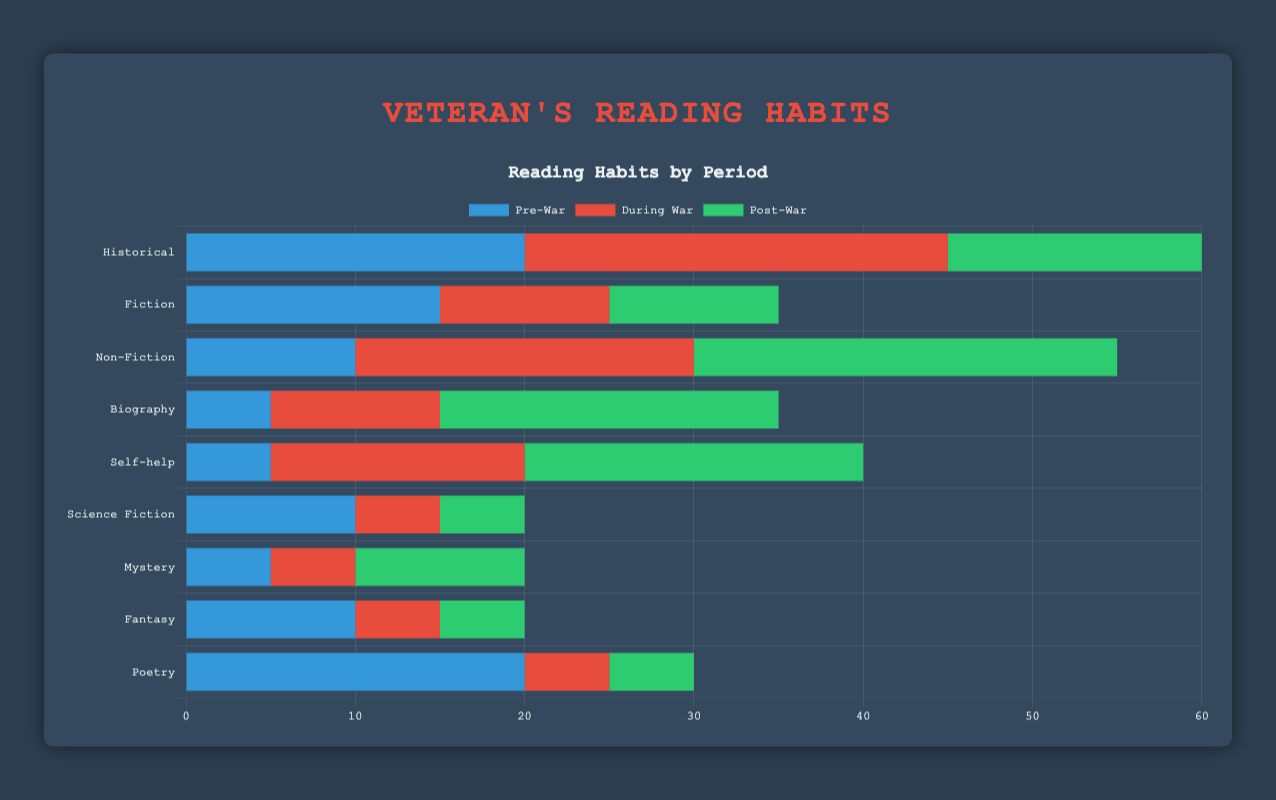What genre saw the biggest increase in reading during the war compared to pre-war? To find the biggest increase, we need to check the differences for each genre between the pre-war and during-war periods. For example, Historical increased by 25 - 20 = 5, Non-Fiction increased by 20 - 10 = 10, etc. After checking all genres, Non-Fiction has the highest increase (10).
Answer: Non-Fiction Which genre had the highest reading percentage post-war? By comparing the numbers in the post-war period, the highest value is for Non-Fiction at 25. Hence, Non-Fiction had the highest reading percentage post-war.
Answer: Non-Fiction How did poetry reading change from the pre-war to the post-war period? Poetry reading went from 20 in the pre-war period to 5 in the post-war period. Therefore, it decreased by 20 - 5 = 15.
Answer: Decreased by 15 Which periods had equal reading values for Fantasy? By checking each period for Fantasy, we see that in the pre-war and post-war periods, both values are 10 and 5, respectively.
Answer: None What is the total reading count for Science Fiction across all periods? Summing up Science Fiction values for all periods: 10 (pre-war) + 5 (during war) + 5 (post-war) = 20.
Answer: 20 In which period did Self-help and Biography have the same readings? By checking each period, we see that both genres had the same reading value of 20 in the post-war period.
Answer: Post-war Which genre experienced an increase in reading during the war and again post-war? Checking the changes in each genre, Biography increased from 5 (pre-war) to 10 (during war) to 20 (post-war).
Answer: Biography What's the difference in Fiction reading between pre-war and during-war periods? For Fiction, the pre-war value is 15, and the during-war value is 10. The difference is 15 - 10 = 5.
Answer: 5 What is the average reading value of Historical across all periods? The values for Historical are 20 (pre-war), 25 (during war), and 15 (post-war). Their sum is 20 + 25 + 15 = 60. The average is 60 / 3 = 20.
Answer: 20 Which genre had the highest consistent reading count across all periods? Comparing the values across all periods, Historical has consistent high values: 20, 25, and 15. None of the other genres have consistently high values categorically across all periods.
Answer: Historical 